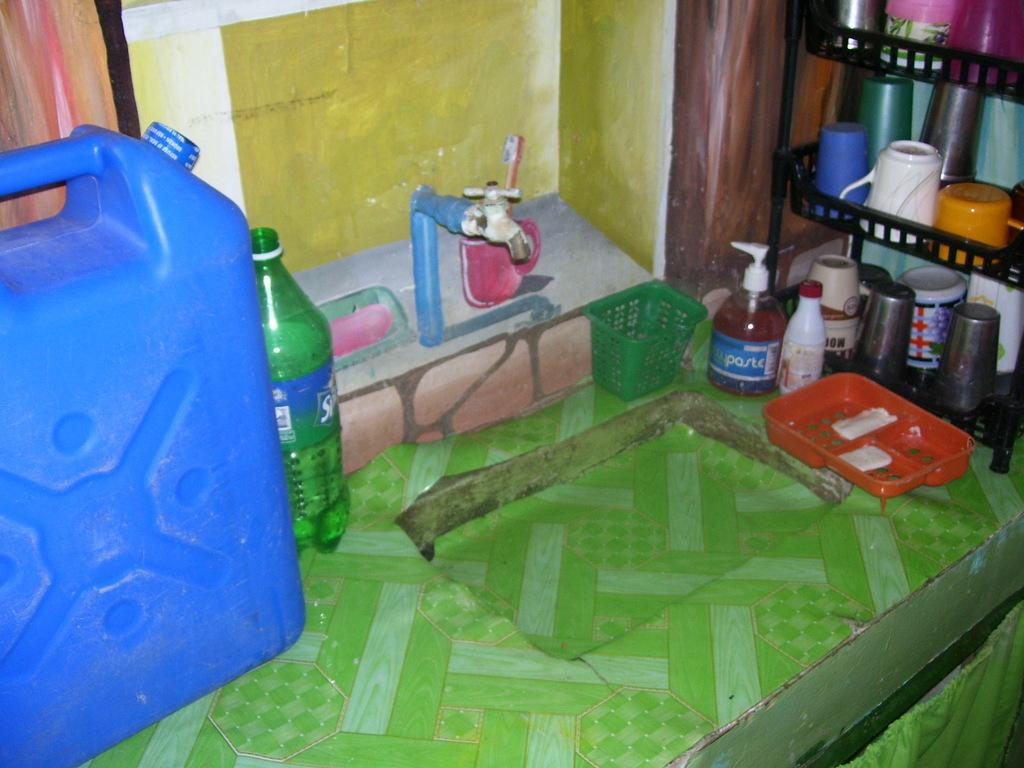What is one of the objects in the image? There is a bottle in the image. What can be used to dispense water in the image? There is a tap in the image. What is the purpose of the sink in the image? The sink is likely used for washing or cleaning purposes. What is another container present in the image? There is a can in the image. What can be used for drinking in the image? There are glasses in the image. What is used to store items on the shelf in the image? There is a rack on the shelf in the image. What can be seen in the background of the image? There is a wall visible in the background of the image. Are there any bones visible in the image? No, there are no bones present in the image. What level of difficulty is the cobweb in the image? There is no cobweb present in the image. 